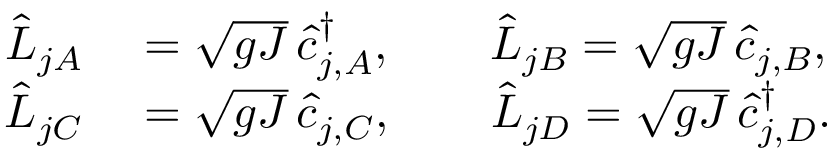Convert formula to latex. <formula><loc_0><loc_0><loc_500><loc_500>\begin{array} { r l } { \hat { L } _ { j A } } & = \sqrt { g J } \, \hat { c } _ { j , A } ^ { \dagger } , \quad \hat { L } _ { j B } = \sqrt { g J } \, \hat { c } _ { j , B } , } \\ { \hat { L } _ { j C } } & = \sqrt { g J } \, \hat { c } _ { j , C } , \quad \hat { L } _ { j D } = \sqrt { g J } \, \hat { c } _ { j , D } ^ { \dagger } . } \end{array}</formula> 